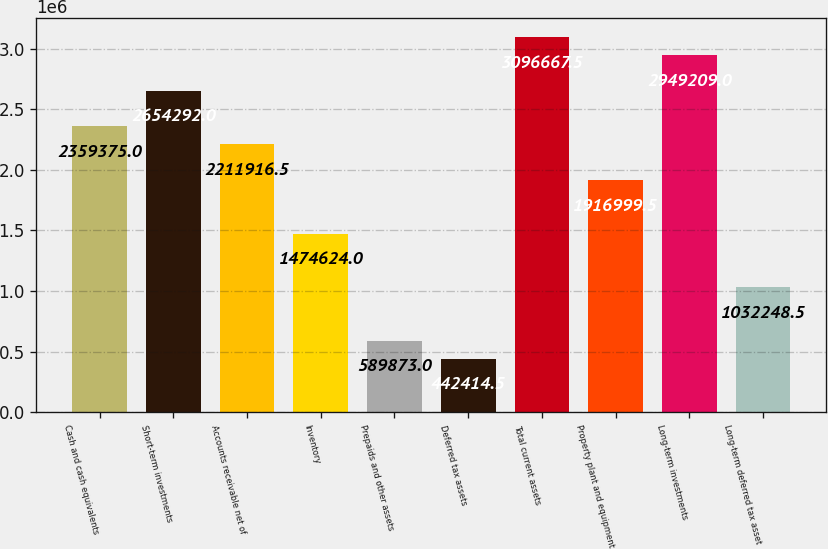Convert chart to OTSL. <chart><loc_0><loc_0><loc_500><loc_500><bar_chart><fcel>Cash and cash equivalents<fcel>Short-term investments<fcel>Accounts receivable net of<fcel>Inventory<fcel>Prepaids and other assets<fcel>Deferred tax assets<fcel>Total current assets<fcel>Property plant and equipment<fcel>Long-term investments<fcel>Long-term deferred tax asset<nl><fcel>2.35938e+06<fcel>2.65429e+06<fcel>2.21192e+06<fcel>1.47462e+06<fcel>589873<fcel>442414<fcel>3.09667e+06<fcel>1.917e+06<fcel>2.94921e+06<fcel>1.03225e+06<nl></chart> 